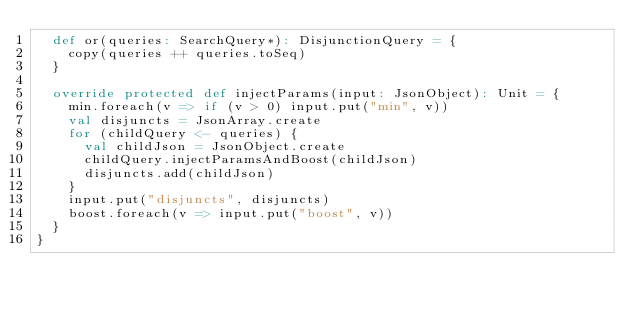Convert code to text. <code><loc_0><loc_0><loc_500><loc_500><_Scala_>  def or(queries: SearchQuery*): DisjunctionQuery = {
    copy(queries ++ queries.toSeq)
  }

  override protected def injectParams(input: JsonObject): Unit = {
    min.foreach(v => if (v > 0) input.put("min", v))
    val disjuncts = JsonArray.create
    for (childQuery <- queries) {
      val childJson = JsonObject.create
      childQuery.injectParamsAndBoost(childJson)
      disjuncts.add(childJson)
    }
    input.put("disjuncts", disjuncts)
    boost.foreach(v => input.put("boost", v))
  }
}
</code> 